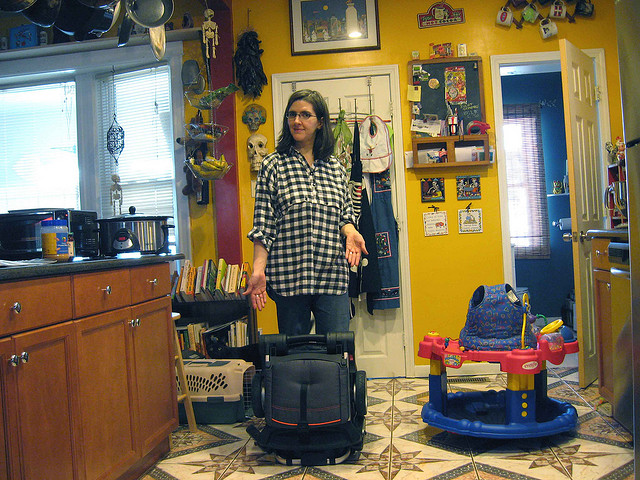<image>What type of dishes are hanging above the door? I am not sure what type of dishes are hanging above the door. They could be mugs or cups. What type of dishes are hanging above the door? I don't know what type of dishes are hanging above the door. It can be mugs, coffee cups, cups or none at all. 